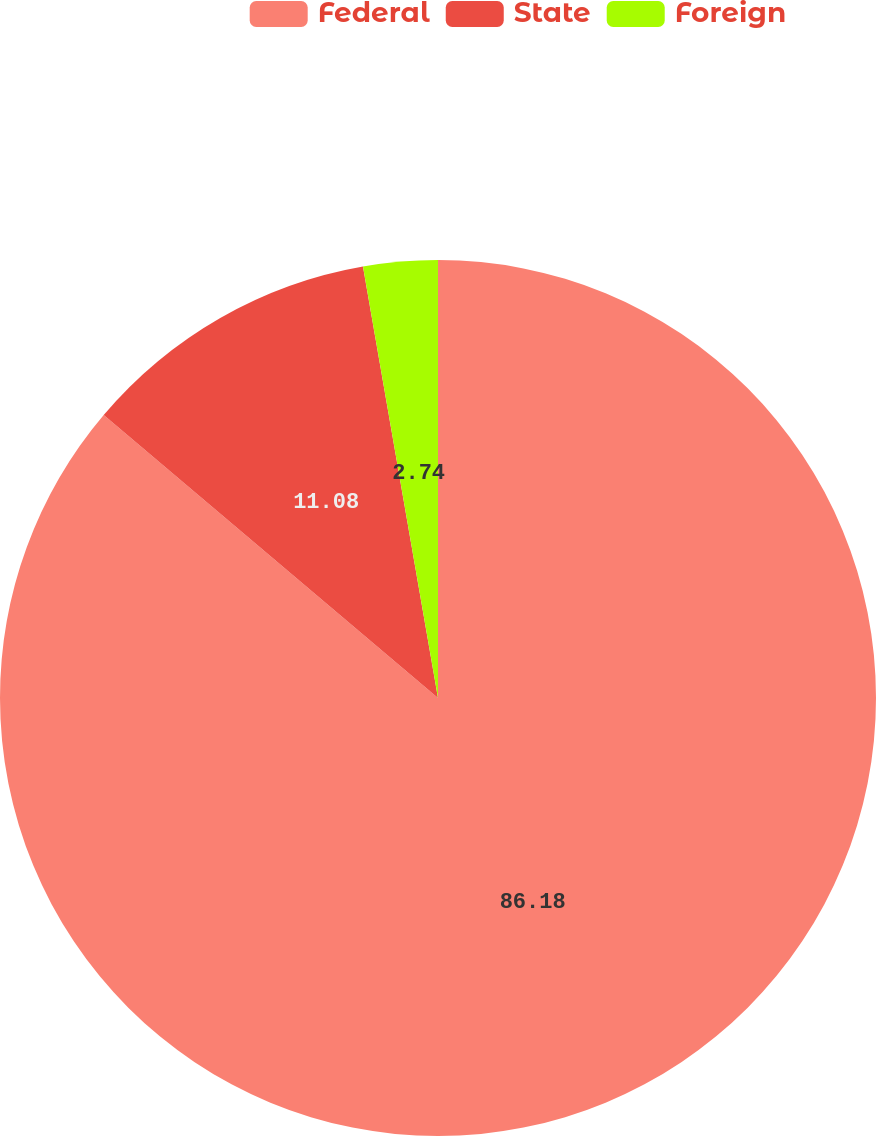<chart> <loc_0><loc_0><loc_500><loc_500><pie_chart><fcel>Federal<fcel>State<fcel>Foreign<nl><fcel>86.18%<fcel>11.08%<fcel>2.74%<nl></chart> 